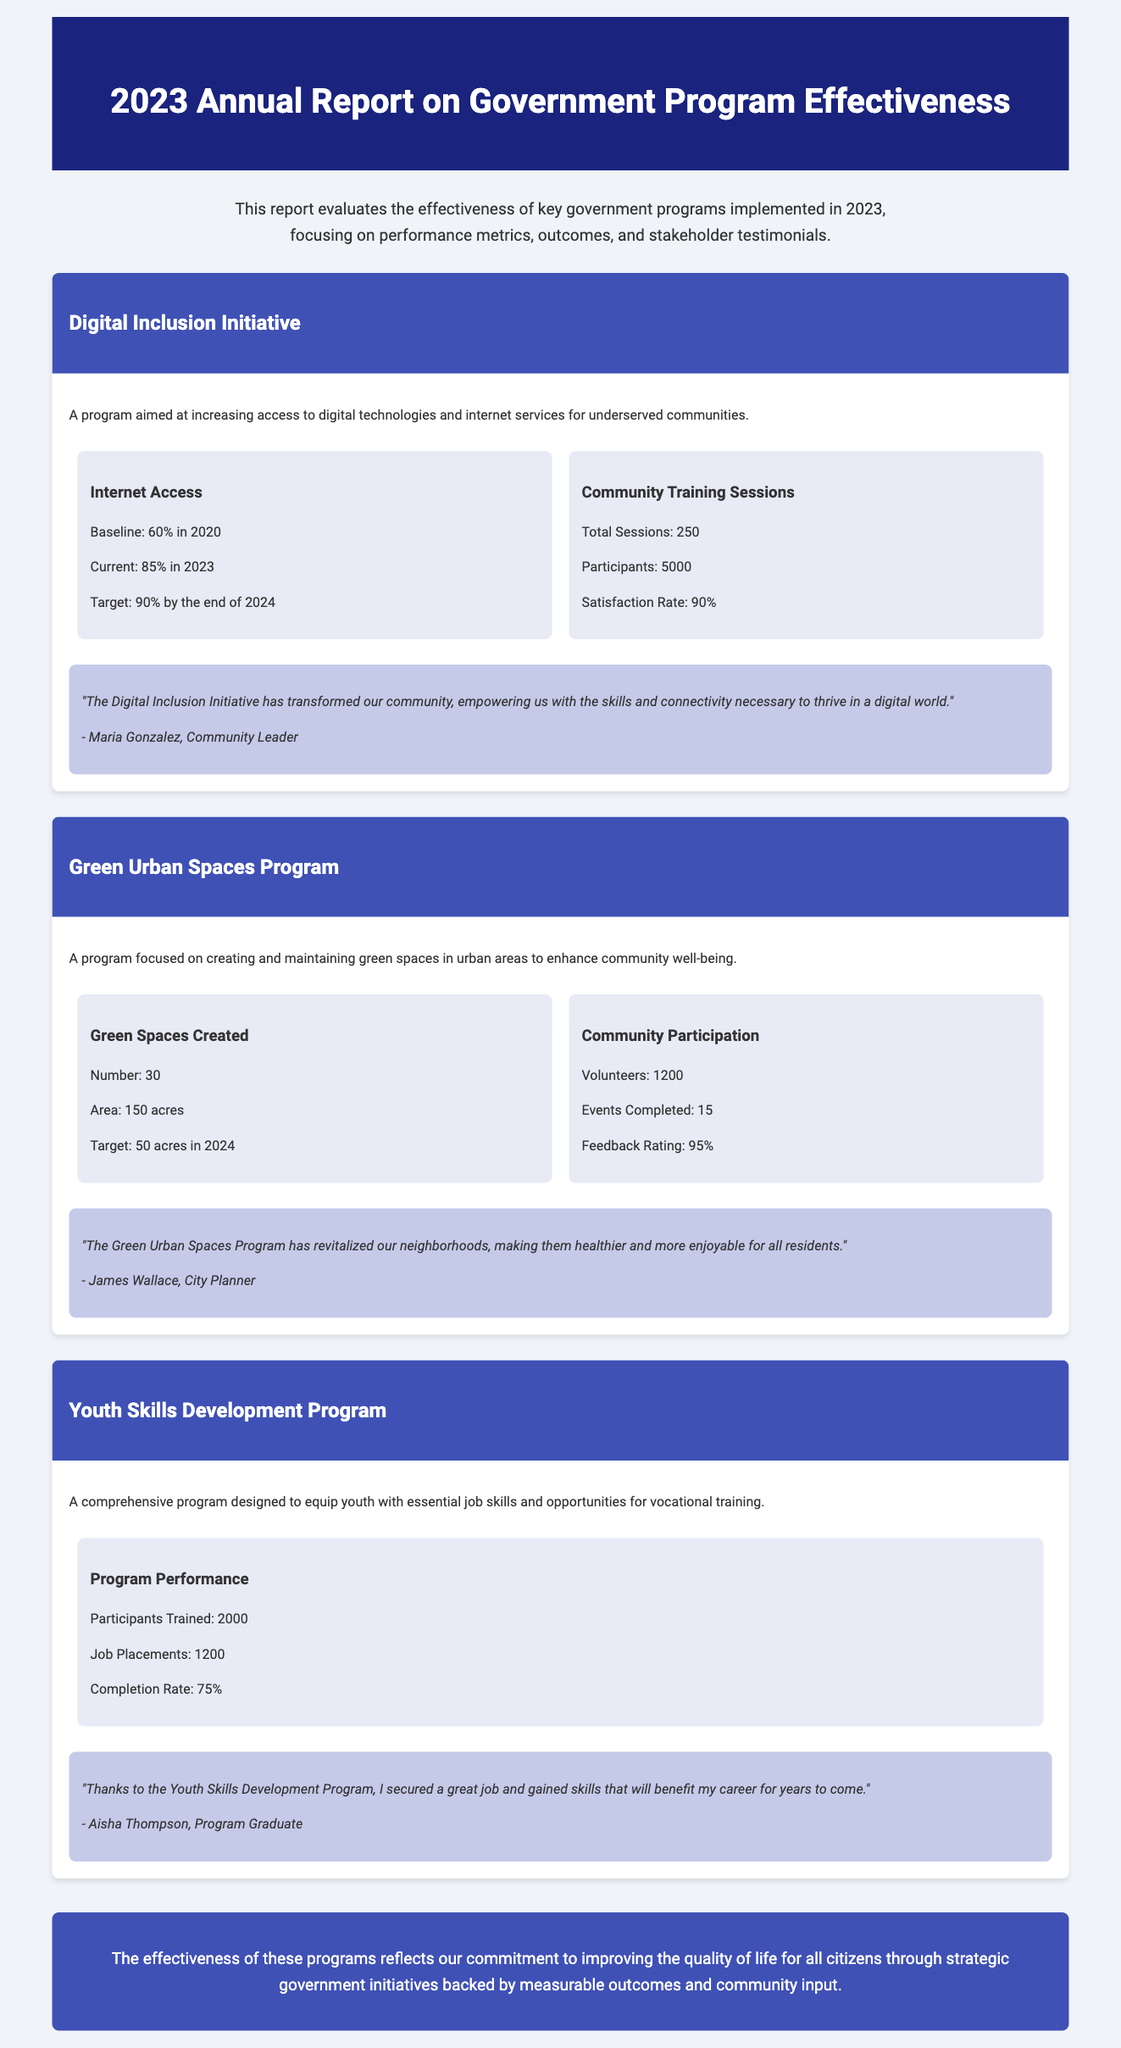What is the baseline internet access percentage in 2020? The document states that the baseline internet access in 2020 was 60%.
Answer: 60% How many community training sessions were conducted? The document specifies that a total of 250 community training sessions were conducted.
Answer: 250 What is the satisfaction rate for community training participants? According to the report, the satisfaction rate for the community training participants is 90%.
Answer: 90% How much area in acres of green spaces was created? The document mentions that 150 acres of green spaces were created.
Answer: 150 acres What is the number of job placements in the Youth Skills Development Program? The report indicates that there were 1200 job placements in the Youth Skills Development Program.
Answer: 1200 What is the feedback rating for community participation in the Green Urban Spaces Program? The document states that the feedback rating for community participation is 95%.
Answer: 95% Who is the community leader that provided a testimonial for the Digital Inclusion Initiative? The document provides a testimonial from Maria Gonzalez, a community leader.
Answer: Maria Gonzalez How many volunteers participated in the Green Urban Spaces Program? The report indicates that there were 1200 volunteers who participated in the program.
Answer: 1200 What is the completion rate for the Youth Skills Development Program? The document mentions that the completion rate for the program is 75%.
Answer: 75% 